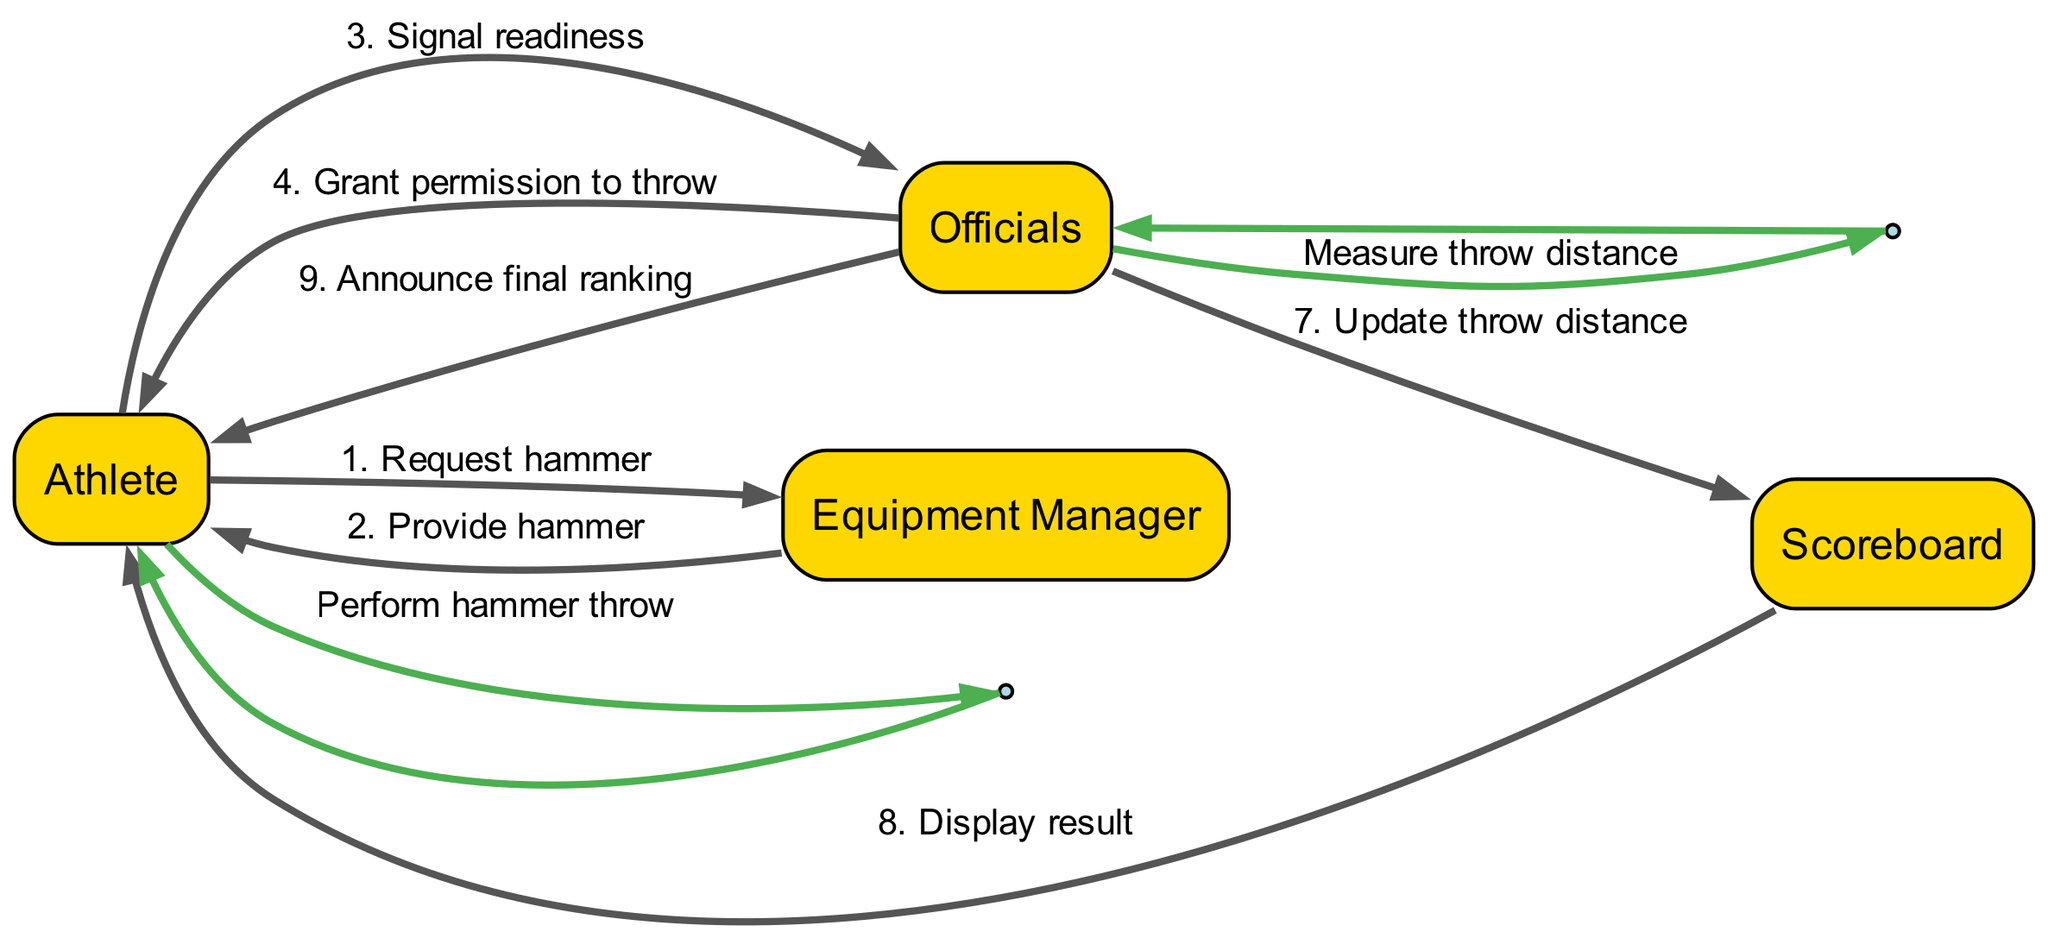What is the first action in the sequence? The first action in the sequence is initiated by the Athlete who requests the hammer from the Equipment Manager.
Answer: Request hammer Who provides the hammer to the athlete? The Equipment Manager is responsible for providing the hammer to the Athlete after the request is made.
Answer: Equipment Manager What action follows the signal of readiness by the athlete? After the Athlete signals readiness, the next action is the Officials granting permission to throw, indicating that the competition is ready to proceed.
Answer: Grant permission to throw How many total actions are performed by the Officials? The Officials perform three distinct actions in the sequence, which are measuring throw distance, updating the throw distance on the scoreboard, and announcing the final ranking.
Answer: Three What is displayed to the athlete after updating the throw distance? After the Officials update the throw distance in the scoreboard, the next action is the Scoreboard displaying the result back to the Athlete.
Answer: Display result Which actor performs a self-loop action in the sequence? The Athlete performs a self-loop action by executing the hammer throw before the Officials measure the distance, indicating a personal action without interaction with others at that moment.
Answer: Athlete What is the last action in the sequence diagram? The last action in the sequence is the Officials announcing the final ranking to the Athlete, which wraps up the competition process.
Answer: Announce final ranking Who is responsible for measuring the throw distance? The Officials are responsible for measuring the throw distance after the Athlete performs the hammer throw, indicated as part of their designated duties in the sequence.
Answer: Officials 